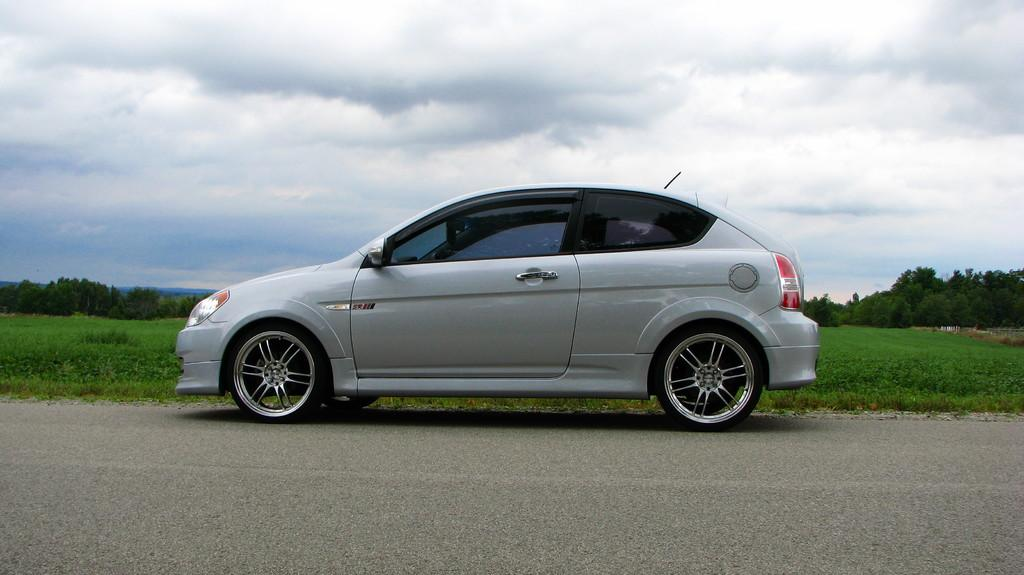What is the main subject of the image? The main subject of the image is a car. Where is the car located in the image? The car is on the road in the image. What is the color of the car? The car is grey in color. What can be seen in the background of the image? In the background of the image, there is grass, trees, and the sky. What is the condition of the sky in the image? The sky is visible in the background of the image, and clouds are present. What type of print can be seen on the cushion in the image? There is no cushion present in the image; it features a car on the road. How many people are going on a trip in the image? There is no indication of a trip or any people in the image; it only shows a car on the road. 